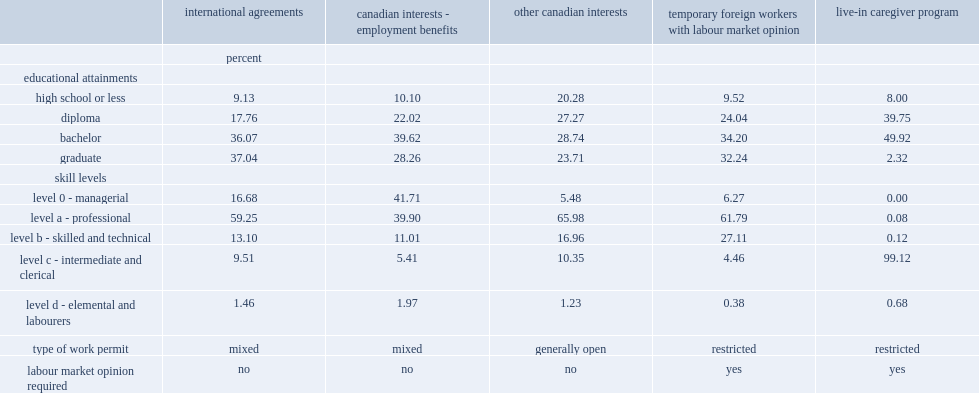What is the percentage of those in the ia group who have at least a bachelor's degree? 73.11. What is the percentage of the oci group and live-in caregivers who have at least a bachelor's degree? 52.24. What is the percentage of the ci-eb group who work in managerial jobs? 41.71. What is the percentage of the ci-eb group who work in jobs requiring professional skills? 39.9. What is the percentage of the ia group who work in jobs requiring professional skills? 59.25. What is the percentage of the oci group who work in jobs requiring professional skills? 65.98. What is the percentage of the tfw-lmo group who work in jobs requiring professional skills? 61.79. 